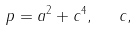<formula> <loc_0><loc_0><loc_500><loc_500>p = a ^ { 2 } + c ^ { 4 } , \ \ c ,</formula> 